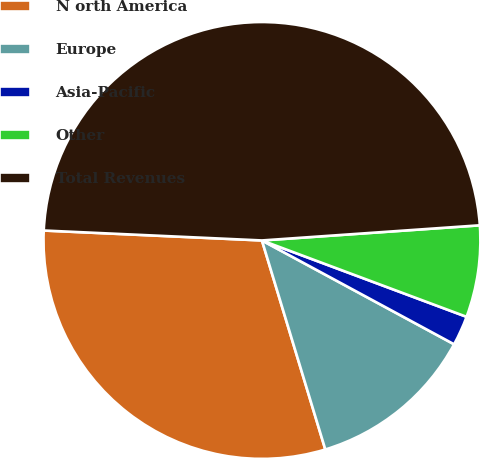<chart> <loc_0><loc_0><loc_500><loc_500><pie_chart><fcel>N orth America<fcel>Europe<fcel>Asia-Pacific<fcel>Other<fcel>Total Revenues<nl><fcel>30.41%<fcel>12.43%<fcel>2.2%<fcel>6.79%<fcel>48.17%<nl></chart> 